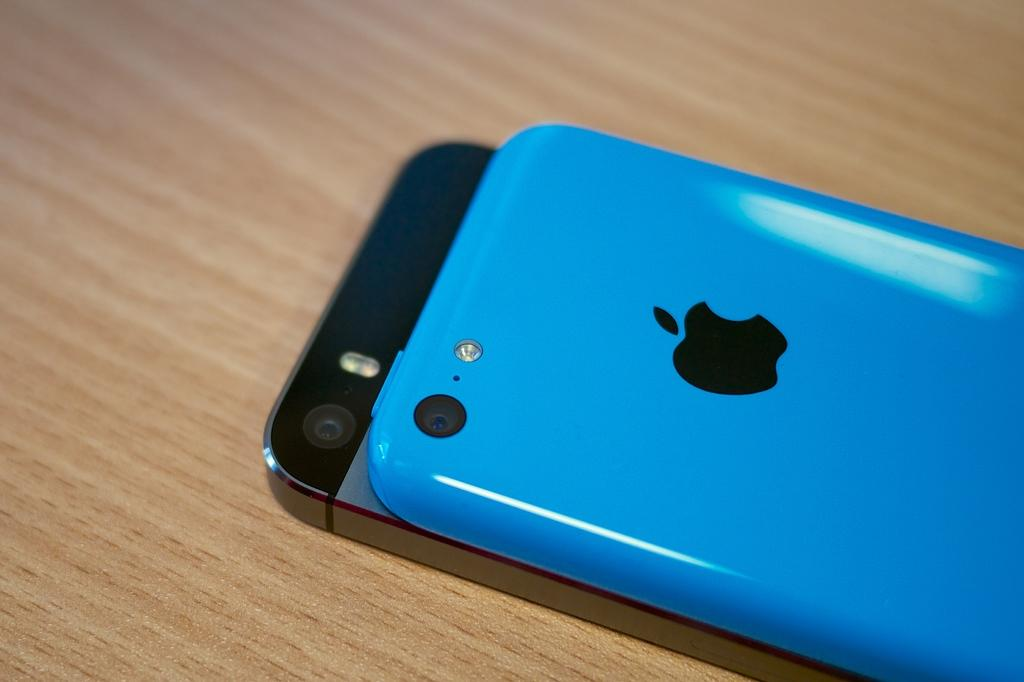How many mobile phones are visible in the image? There are two mobile phones in the image. What is the surface on which the mobile phones are placed? The mobile phones are placed on a wooden board. Can you identify any specific brand of one of the mobile phones? Yes, one of the mobile phones has an apple logo, which indicates it is an Apple product. What color is the mobile case cover? The mobile case cover is blue in color. What type of lawyer is depicted playing with a bike in the image? There is no lawyer or bike present in the image; it only features two mobile phones placed on a wooden board. 